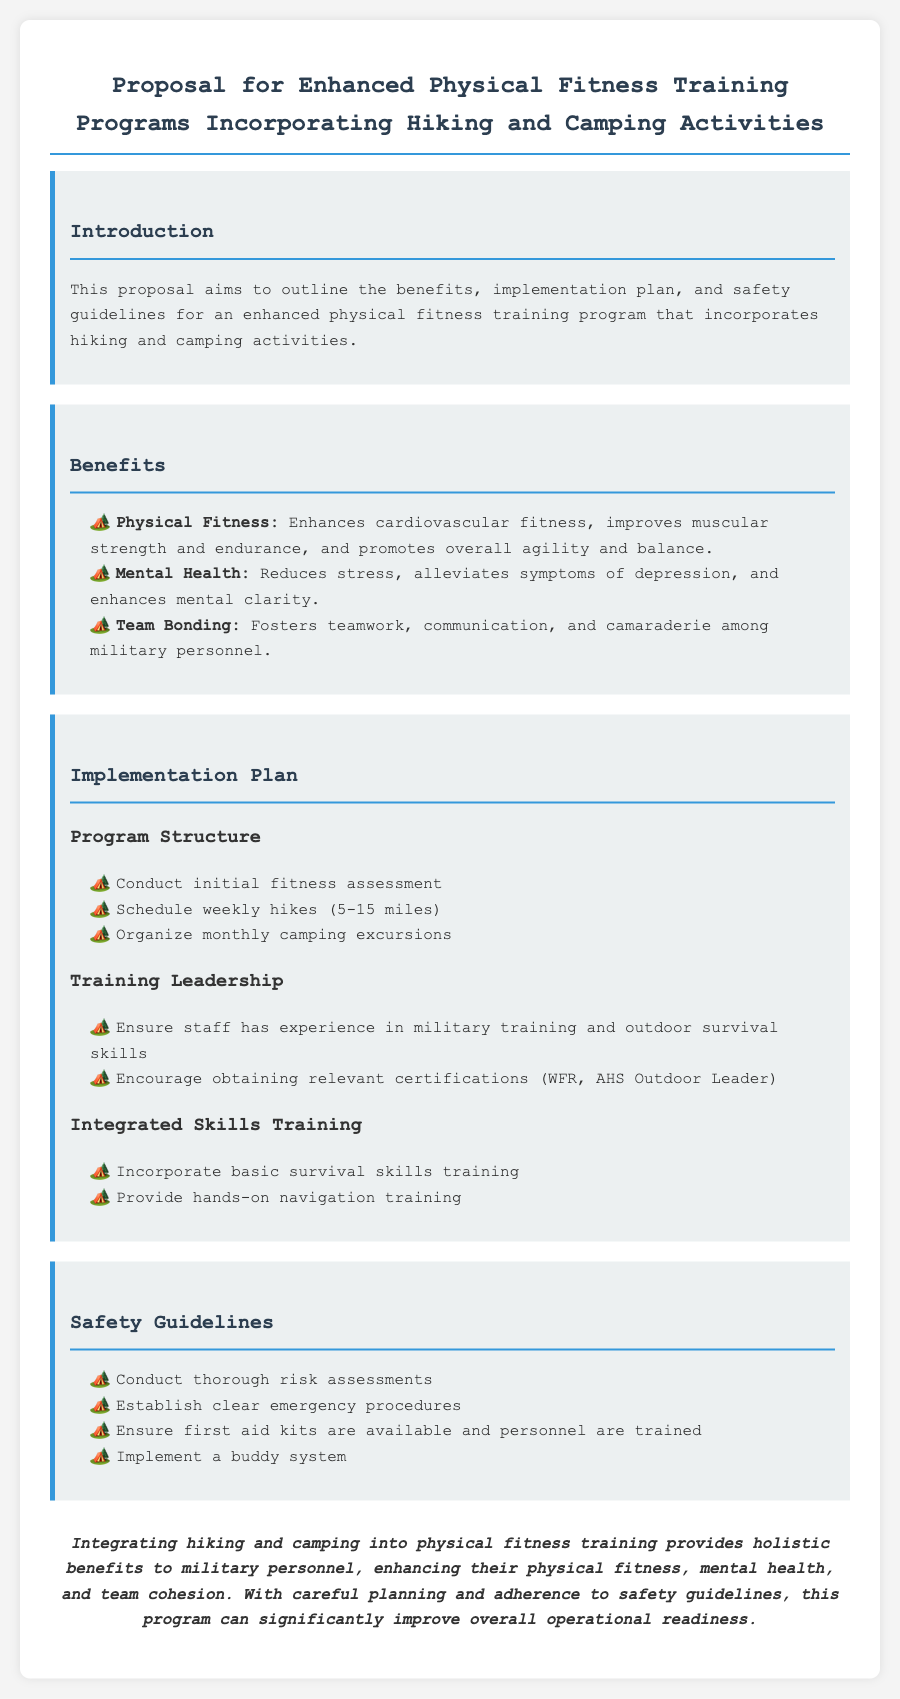what is the title of the proposal? The title of the proposal is stated at the top of the document.
Answer: Proposal for Enhanced Physical Fitness Training Programs Incorporating Hiking and Camping Activities how many miles are the scheduled weekly hikes? The document specifies a range for the weekly hikes in the implementation plan section.
Answer: 5-15 miles what is one of the benefits mentioned for mental health? The benefits section lists specific advantages for mental health, which is one area of focus in the document.
Answer: Reduces stress what is an essential aspect of training leadership? The implementation plan highlights key requirements for training leadership in the program.
Answer: Experience in military training and outdoor survival skills what should be established according to the safety guidelines? The safety guidelines section emphasizes important procedures that need to be in place.
Answer: Clear emergency procedures how often will camping excursions be organized? The implementation plan states the frequency of camping excursions in the program structure.
Answer: Monthly 